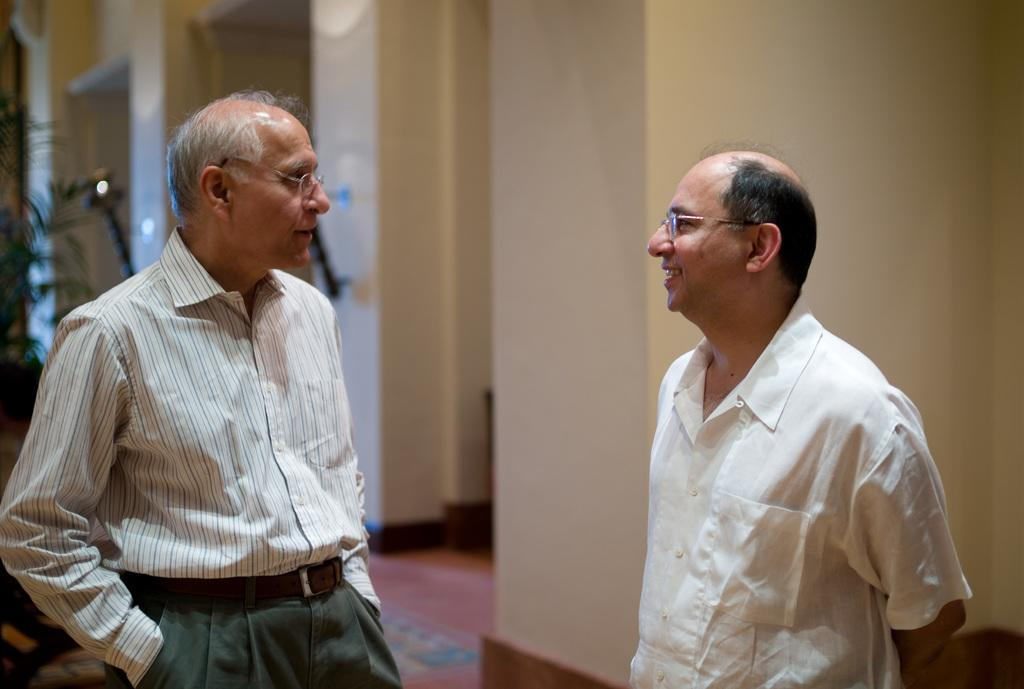How many people are in the image? There are two persons standing in the image. What are the expressions on their faces? Both persons are smiling. What accessory do both persons have in common? Both persons are wearing glasses. What can be seen in the background of the image? There is a wall in the background of the image. What type of vegetation is on the left side of the image? There is a tree on the left side of the image. How would you describe the background's appearance? The background is blurred. What type of judge is depicted in the image? There is no judge present in the image. How does the way the persons are standing in the image reflect their feelings of regret? The persons in the image are smiling and there is no indication of regret in their posture or expressions. 